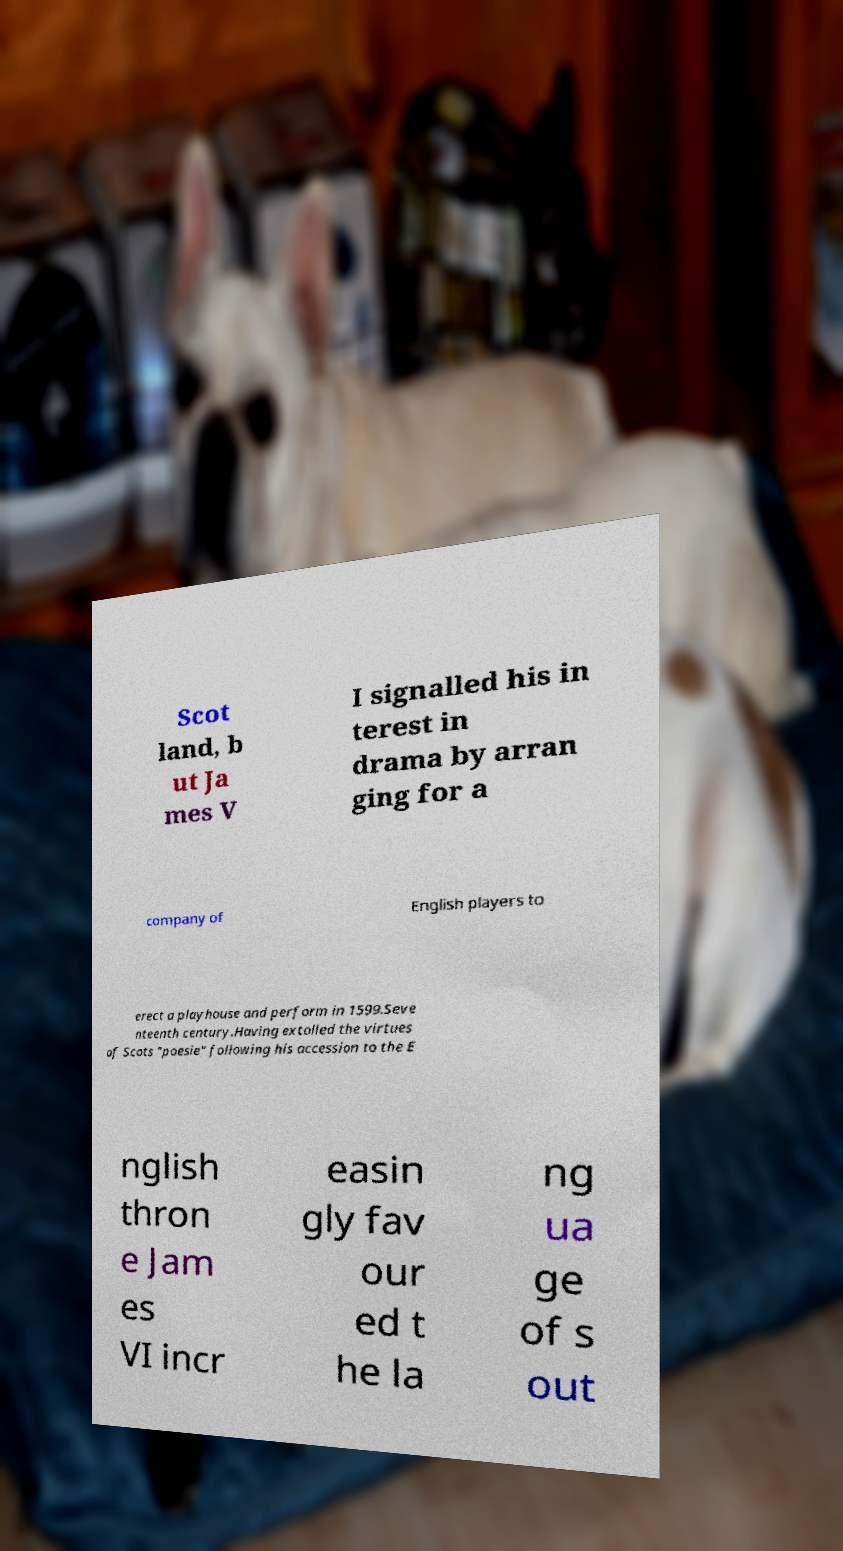There's text embedded in this image that I need extracted. Can you transcribe it verbatim? Scot land, b ut Ja mes V I signalled his in terest in drama by arran ging for a company of English players to erect a playhouse and perform in 1599.Seve nteenth century.Having extolled the virtues of Scots "poesie" following his accession to the E nglish thron e Jam es VI incr easin gly fav our ed t he la ng ua ge of s out 